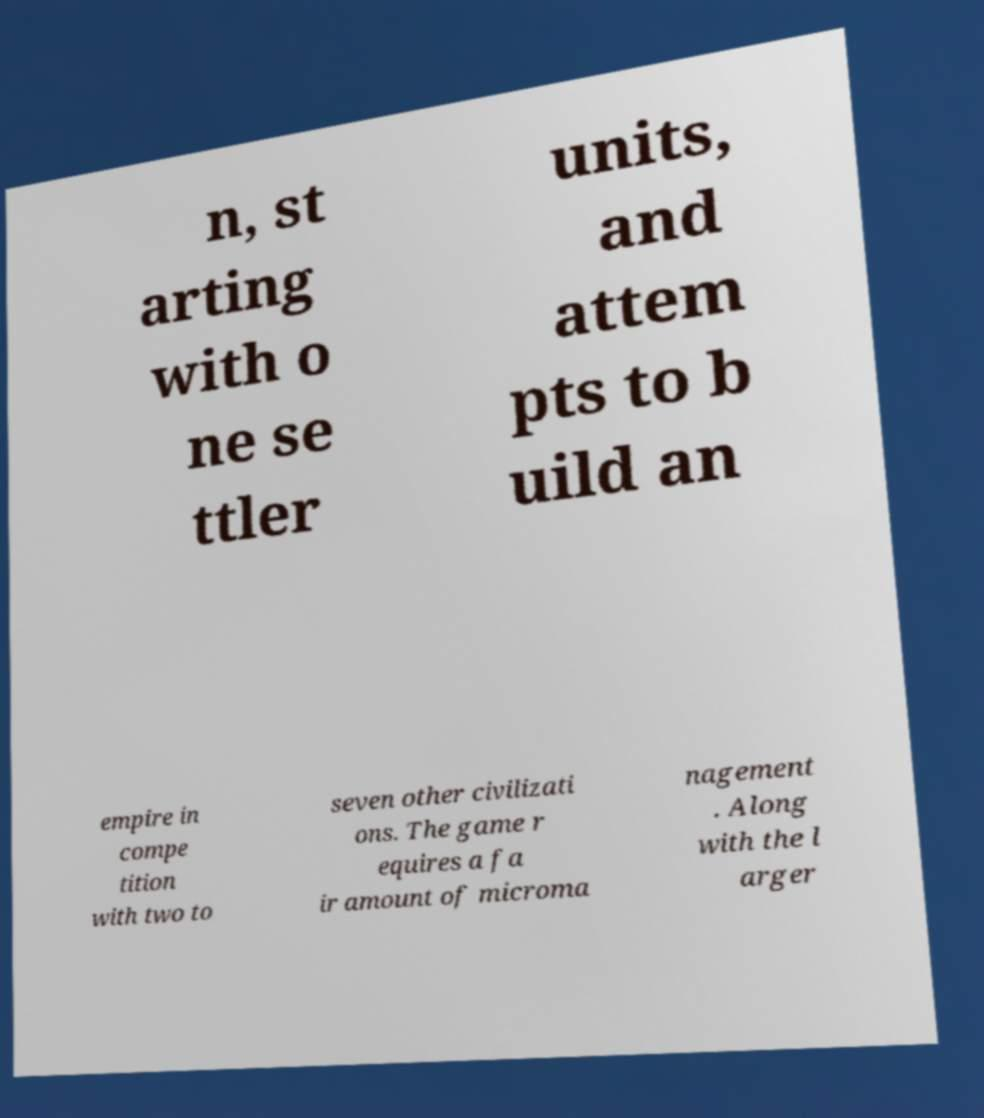Please read and relay the text visible in this image. What does it say? n, st arting with o ne se ttler units, and attem pts to b uild an empire in compe tition with two to seven other civilizati ons. The game r equires a fa ir amount of microma nagement . Along with the l arger 